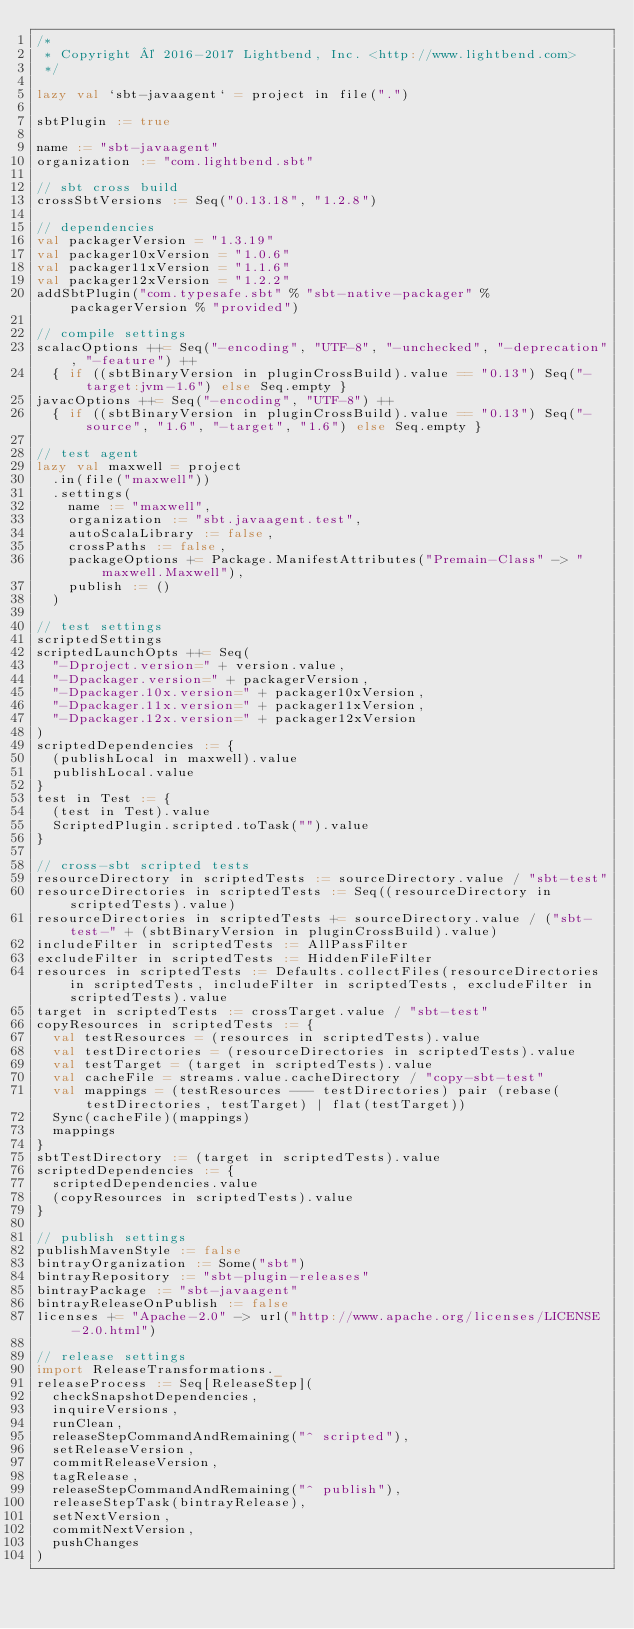<code> <loc_0><loc_0><loc_500><loc_500><_Scala_>/*
 * Copyright © 2016-2017 Lightbend, Inc. <http://www.lightbend.com>
 */

lazy val `sbt-javaagent` = project in file(".")

sbtPlugin := true

name := "sbt-javaagent"
organization := "com.lightbend.sbt"

// sbt cross build
crossSbtVersions := Seq("0.13.18", "1.2.8")

// dependencies
val packagerVersion = "1.3.19"
val packager10xVersion = "1.0.6"
val packager11xVersion = "1.1.6"
val packager12xVersion = "1.2.2"
addSbtPlugin("com.typesafe.sbt" % "sbt-native-packager" % packagerVersion % "provided")

// compile settings
scalacOptions ++= Seq("-encoding", "UTF-8", "-unchecked", "-deprecation", "-feature") ++
  { if ((sbtBinaryVersion in pluginCrossBuild).value == "0.13") Seq("-target:jvm-1.6") else Seq.empty }
javacOptions ++= Seq("-encoding", "UTF-8") ++
  { if ((sbtBinaryVersion in pluginCrossBuild).value == "0.13") Seq("-source", "1.6", "-target", "1.6") else Seq.empty }

// test agent
lazy val maxwell = project
  .in(file("maxwell"))
  .settings(
    name := "maxwell",
    organization := "sbt.javaagent.test",
    autoScalaLibrary := false,
    crossPaths := false,
    packageOptions += Package.ManifestAttributes("Premain-Class" -> "maxwell.Maxwell"),
    publish := ()
  )

// test settings
scriptedSettings
scriptedLaunchOpts ++= Seq(
  "-Dproject.version=" + version.value,
  "-Dpackager.version=" + packagerVersion,
  "-Dpackager.10x.version=" + packager10xVersion,
  "-Dpackager.11x.version=" + packager11xVersion,
  "-Dpackager.12x.version=" + packager12xVersion
)
scriptedDependencies := {
  (publishLocal in maxwell).value
  publishLocal.value
}
test in Test := {
  (test in Test).value
  ScriptedPlugin.scripted.toTask("").value
}

// cross-sbt scripted tests
resourceDirectory in scriptedTests := sourceDirectory.value / "sbt-test"
resourceDirectories in scriptedTests := Seq((resourceDirectory in scriptedTests).value)
resourceDirectories in scriptedTests += sourceDirectory.value / ("sbt-test-" + (sbtBinaryVersion in pluginCrossBuild).value)
includeFilter in scriptedTests := AllPassFilter
excludeFilter in scriptedTests := HiddenFileFilter
resources in scriptedTests := Defaults.collectFiles(resourceDirectories in scriptedTests, includeFilter in scriptedTests, excludeFilter in scriptedTests).value
target in scriptedTests := crossTarget.value / "sbt-test"
copyResources in scriptedTests := {
  val testResources = (resources in scriptedTests).value
  val testDirectories = (resourceDirectories in scriptedTests).value
  val testTarget = (target in scriptedTests).value
  val cacheFile = streams.value.cacheDirectory / "copy-sbt-test"
  val mappings = (testResources --- testDirectories) pair (rebase(testDirectories, testTarget) | flat(testTarget))
  Sync(cacheFile)(mappings)
  mappings
}
sbtTestDirectory := (target in scriptedTests).value
scriptedDependencies := {
  scriptedDependencies.value
  (copyResources in scriptedTests).value
}

// publish settings
publishMavenStyle := false
bintrayOrganization := Some("sbt")
bintrayRepository := "sbt-plugin-releases"
bintrayPackage := "sbt-javaagent"
bintrayReleaseOnPublish := false
licenses += "Apache-2.0" -> url("http://www.apache.org/licenses/LICENSE-2.0.html")

// release settings
import ReleaseTransformations._
releaseProcess := Seq[ReleaseStep](
  checkSnapshotDependencies,
  inquireVersions,
  runClean,
  releaseStepCommandAndRemaining("^ scripted"),
  setReleaseVersion,
  commitReleaseVersion,
  tagRelease,
  releaseStepCommandAndRemaining("^ publish"),
  releaseStepTask(bintrayRelease),
  setNextVersion,
  commitNextVersion,
  pushChanges
)
</code> 